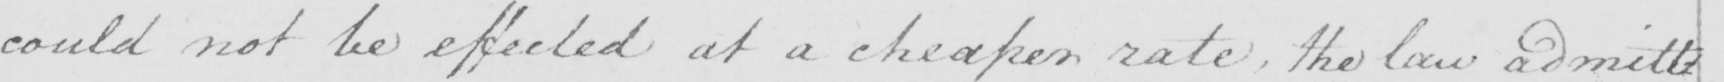Can you tell me what this handwritten text says? could not be effected at a cheaper rate , the law admitt= 